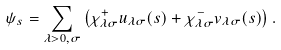Convert formula to latex. <formula><loc_0><loc_0><loc_500><loc_500>\psi _ { s } = \sum _ { \lambda > 0 , \sigma } \left ( \chi ^ { + } _ { \lambda \sigma } u _ { \lambda \sigma } ( s ) + \chi ^ { - } _ { \lambda \sigma } v _ { \lambda \sigma } ( s ) \right ) .</formula> 